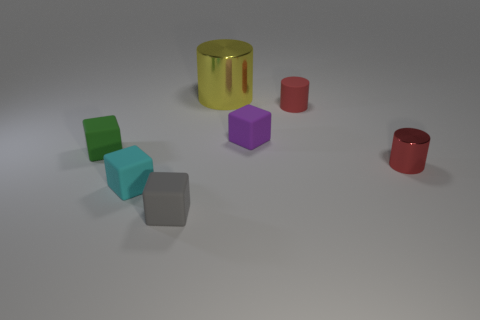What number of balls are either green objects or gray objects?
Keep it short and to the point. 0. Is there anything else that has the same material as the green block?
Provide a short and direct response. Yes. What material is the small red object on the left side of the red object that is right of the matte object that is on the right side of the small purple cube?
Give a very brief answer. Rubber. What is the material of the object that is the same color as the rubber cylinder?
Make the answer very short. Metal. What number of other small things are the same material as the yellow thing?
Offer a very short reply. 1. There is a red cylinder that is behind the green block; does it have the same size as the tiny green rubber object?
Keep it short and to the point. Yes. The tiny cylinder that is the same material as the tiny purple cube is what color?
Give a very brief answer. Red. Is there any other thing that is the same size as the purple cube?
Provide a succinct answer. Yes. How many small cyan objects are behind the green cube?
Provide a short and direct response. 0. Is the color of the rubber cube that is to the right of the yellow metallic cylinder the same as the small cylinder that is behind the green cube?
Provide a succinct answer. No. 